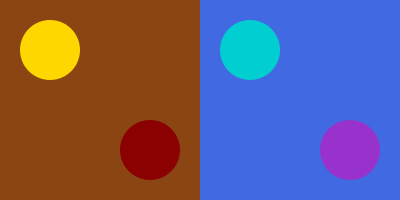How does the color palette in early Christian mosaics differ from that of later Medieval art, and what might this suggest about the evolution of artistic expression within religious contexts? 1. Early Christian color palette:
   - Dominated by earthy tones (represented by the brown background)
   - Limited use of vibrant colors (gold and dark red circles)
   - Colors often symbolize religious concepts (e.g., gold for divinity, red for martyrdom)

2. Medieval color palette:
   - Shift towards cooler, more diverse hues (blue background)
   - Introduction of brighter, more varied colors (turquoise and purple circles)
   - Expanded symbolic color use and decorative purposes

3. Analysis of the transition:
   - Early Christian art shows a restrained palette, reflecting strict adherence to religious themes
   - Medieval art demonstrates a broader range of colors, indicating increased artistic freedom
   - The shift suggests a gradual relaxation of artistic constraints within religious contexts

4. Implications for artistic expression:
   - Early Christian art: limited creativity due to focus on conveying religious messages
   - Medieval art: greater artistic exploration while still maintaining religious significance
   - The change implies an evolution in the relationship between art and religion over time

5. Critique of artistic development:
   - Early Christian art's limited palette may be seen as a constraint on artistic creativity
   - Medieval art's expanded palette could be interpreted as a sign of growing artistic independence
   - The transition reflects broader cultural and societal changes influencing religious art
Answer: Transition from limited, earthy tones to diverse, vibrant hues, suggesting increased artistic freedom within religious contexts. 